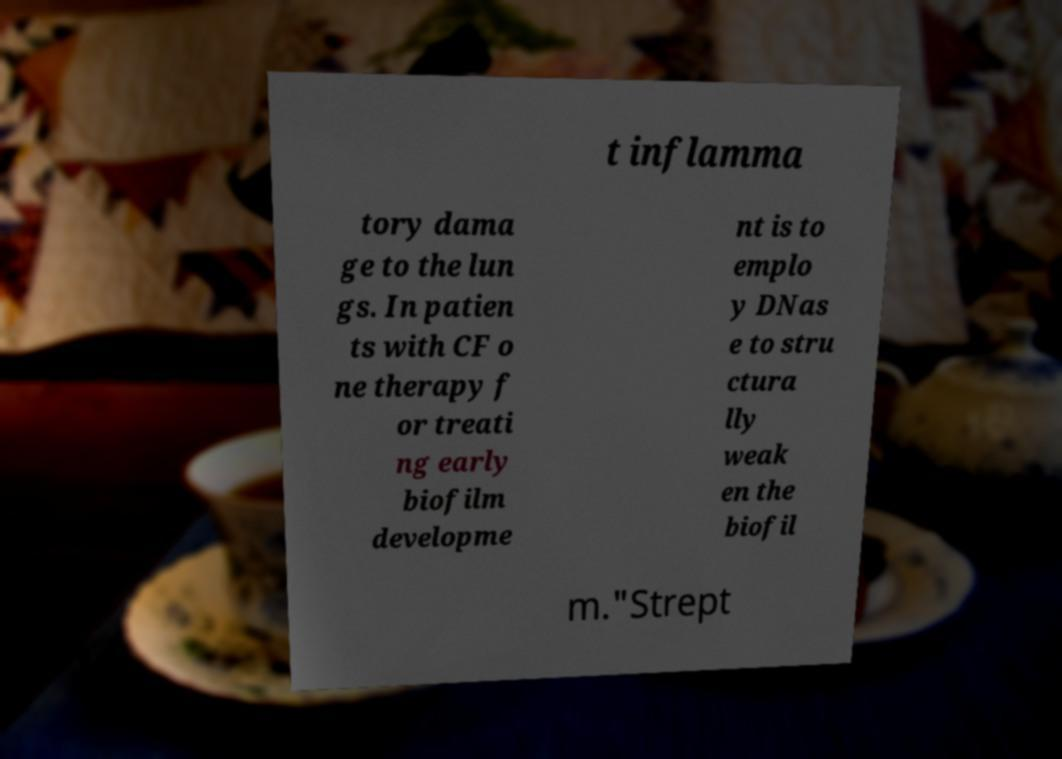Please identify and transcribe the text found in this image. t inflamma tory dama ge to the lun gs. In patien ts with CF o ne therapy f or treati ng early biofilm developme nt is to emplo y DNas e to stru ctura lly weak en the biofil m."Strept 